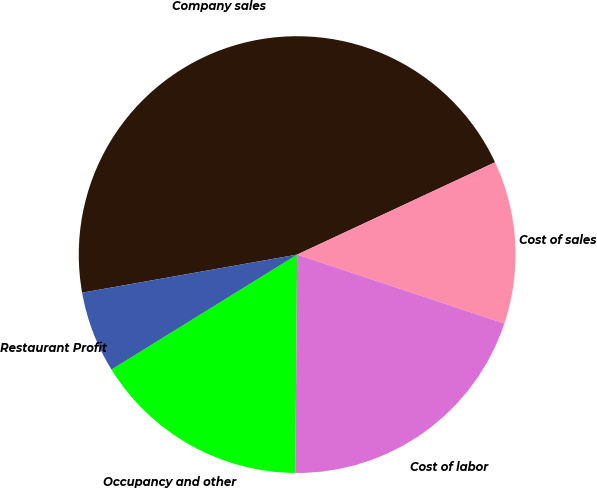<chart> <loc_0><loc_0><loc_500><loc_500><pie_chart><fcel>Company sales<fcel>Cost of sales<fcel>Cost of labor<fcel>Occupancy and other<fcel>Restaurant Profit<nl><fcel>45.84%<fcel>12.06%<fcel>20.02%<fcel>16.04%<fcel>6.03%<nl></chart> 